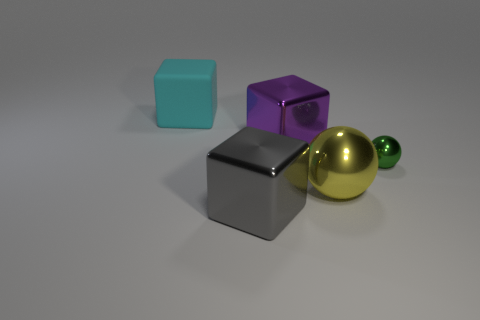Subtract all big matte blocks. How many blocks are left? 2 Subtract all gray cylinders. How many red spheres are left? 0 Subtract all tiny green objects. Subtract all metallic balls. How many objects are left? 2 Add 3 large cyan objects. How many large cyan objects are left? 4 Add 3 small yellow objects. How many small yellow objects exist? 3 Add 5 small green rubber balls. How many objects exist? 10 Subtract all yellow balls. How many balls are left? 1 Subtract 0 yellow cylinders. How many objects are left? 5 Subtract all balls. How many objects are left? 3 Subtract 1 cubes. How many cubes are left? 2 